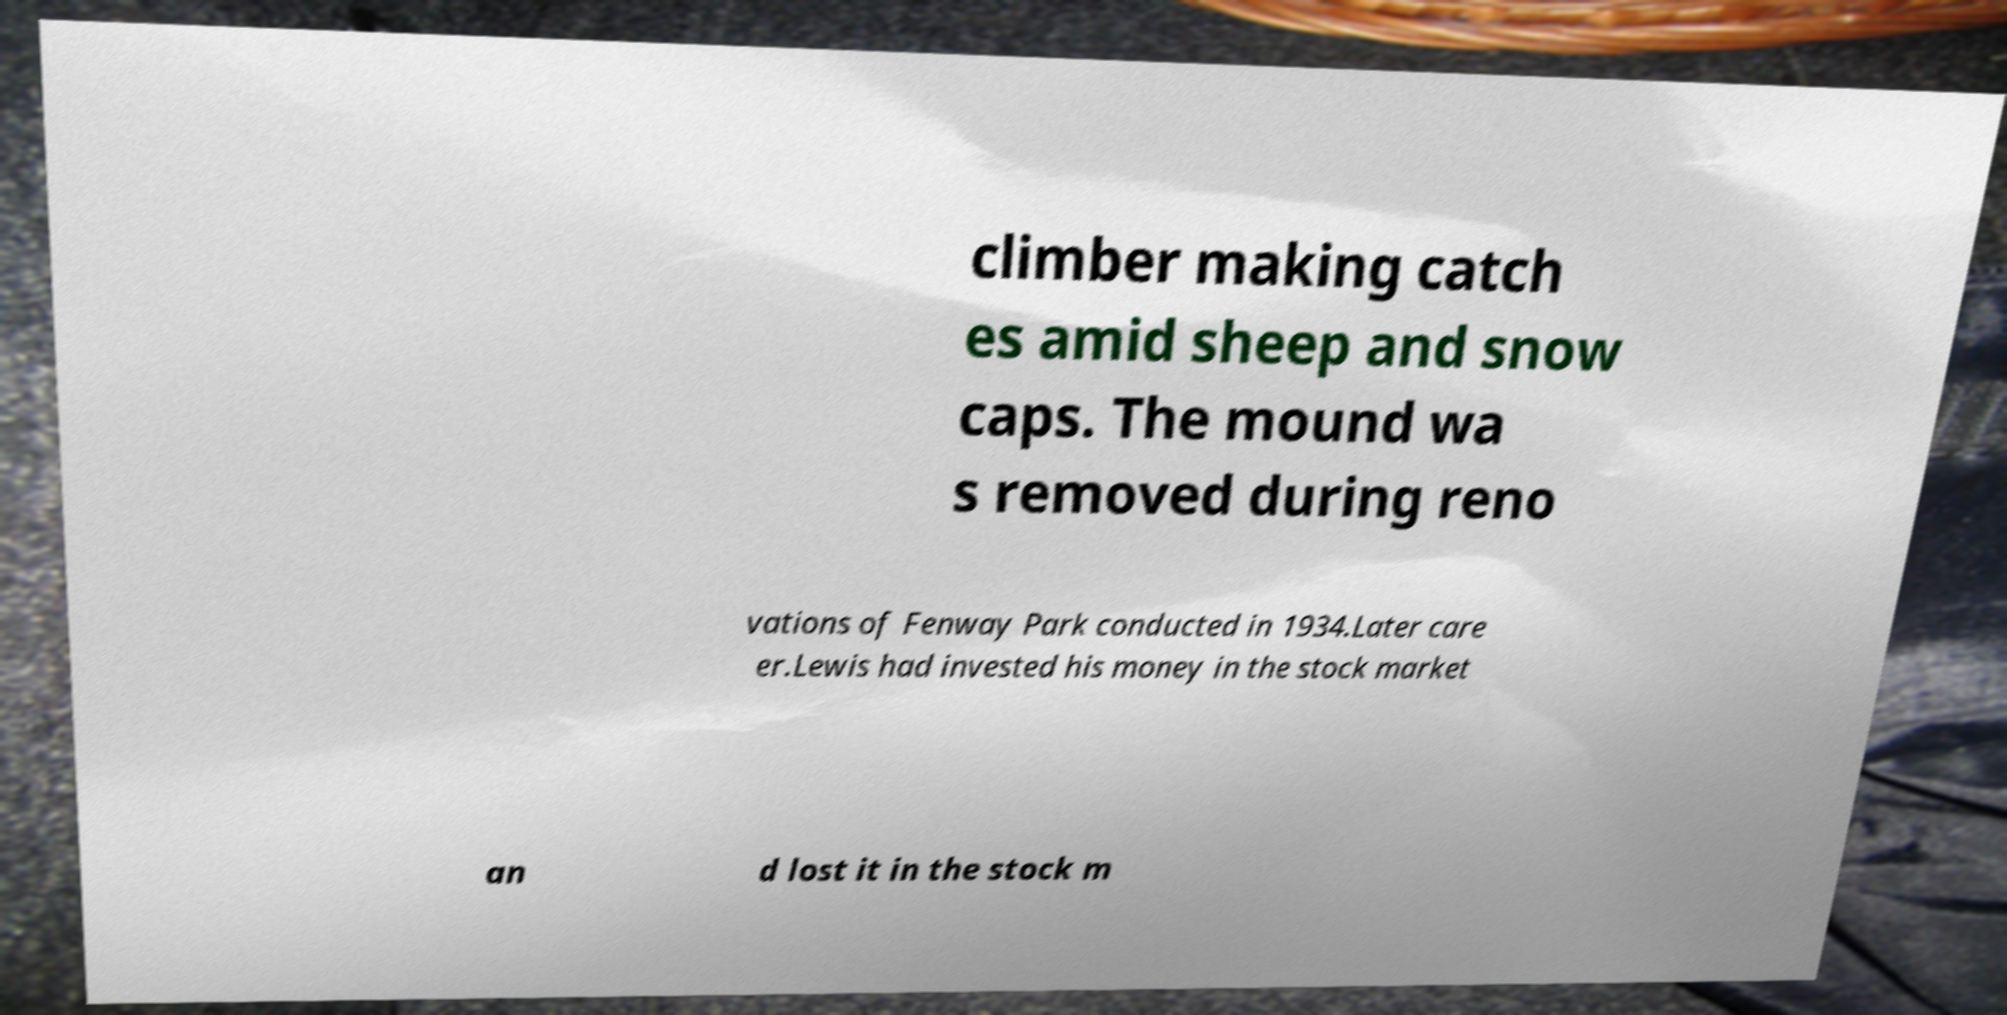Please identify and transcribe the text found in this image. climber making catch es amid sheep and snow caps. The mound wa s removed during reno vations of Fenway Park conducted in 1934.Later care er.Lewis had invested his money in the stock market an d lost it in the stock m 